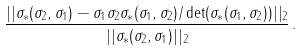Convert formula to latex. <formula><loc_0><loc_0><loc_500><loc_500>\frac { | | \sigma _ { \ast } ( \sigma _ { 2 } , \sigma _ { 1 } ) - \sigma _ { 1 } \sigma _ { 2 } \sigma _ { \ast } ( \sigma _ { 1 } , \sigma _ { 2 } ) / \det ( \sigma _ { \ast } ( \sigma _ { 1 } , \sigma _ { 2 } ) ) | | _ { 2 } } { | | \sigma _ { \ast } ( \sigma _ { 2 } , \sigma _ { 1 } ) | | _ { 2 } } \, .</formula> 